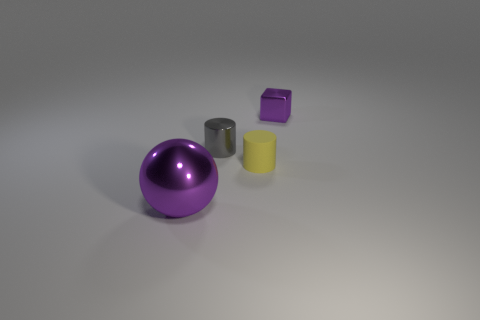Is there anything else that has the same size as the purple metal sphere?
Provide a short and direct response. No. Are there any other things that are the same material as the tiny yellow thing?
Your answer should be compact. No. Is there a thing that has the same color as the block?
Your answer should be compact. Yes. How many objects are small things that are behind the big metallic thing or green shiny cylinders?
Offer a very short reply. 3. What number of other objects are there of the same size as the purple sphere?
Your answer should be very brief. 0. What material is the thing that is behind the gray object that is behind the yellow thing that is in front of the gray object?
Your answer should be compact. Metal. How many spheres are yellow objects or big things?
Ensure brevity in your answer.  1. Is there any other thing that has the same shape as the small yellow rubber object?
Offer a very short reply. Yes. Is the number of shiny objects on the right side of the big purple ball greater than the number of tiny yellow matte cylinders to the left of the gray shiny cylinder?
Give a very brief answer. Yes. How many purple shiny objects are right of the tiny cylinder right of the tiny gray cylinder?
Your answer should be compact. 1. 